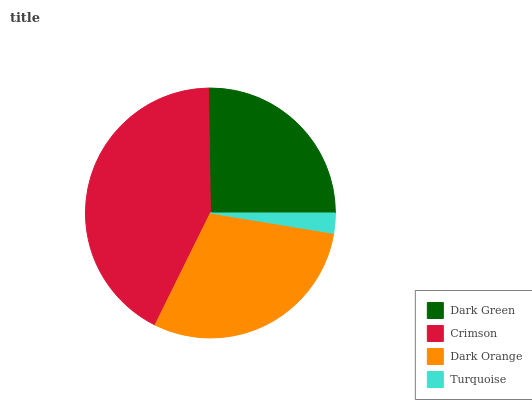Is Turquoise the minimum?
Answer yes or no. Yes. Is Crimson the maximum?
Answer yes or no. Yes. Is Dark Orange the minimum?
Answer yes or no. No. Is Dark Orange the maximum?
Answer yes or no. No. Is Crimson greater than Dark Orange?
Answer yes or no. Yes. Is Dark Orange less than Crimson?
Answer yes or no. Yes. Is Dark Orange greater than Crimson?
Answer yes or no. No. Is Crimson less than Dark Orange?
Answer yes or no. No. Is Dark Orange the high median?
Answer yes or no. Yes. Is Dark Green the low median?
Answer yes or no. Yes. Is Crimson the high median?
Answer yes or no. No. Is Dark Orange the low median?
Answer yes or no. No. 